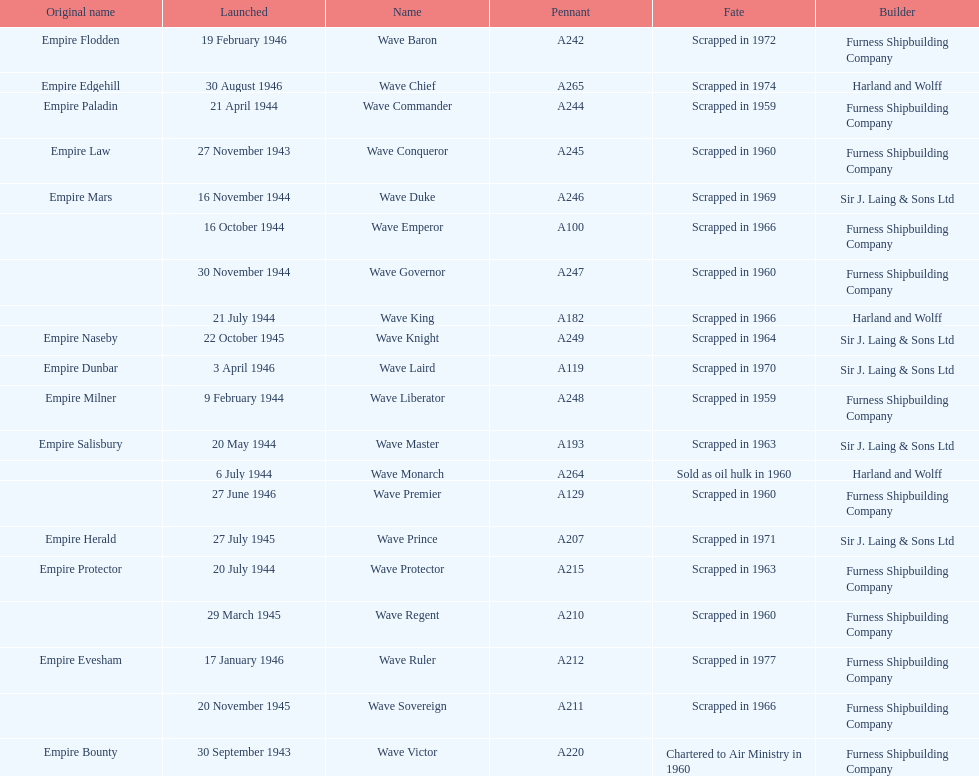How many ships were launched in the year 1944? 9. 